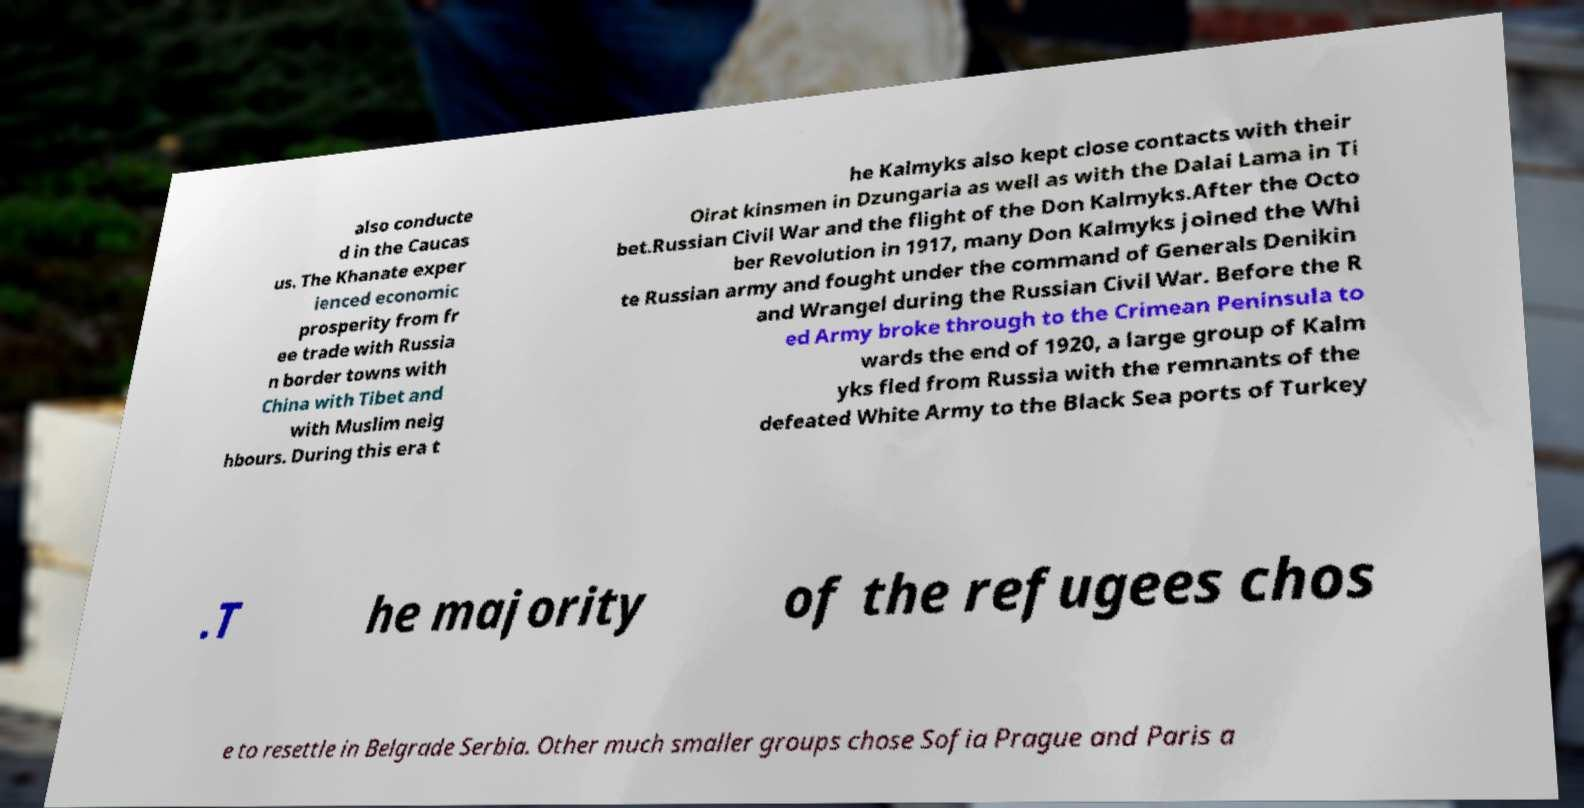Can you read and provide the text displayed in the image?This photo seems to have some interesting text. Can you extract and type it out for me? also conducte d in the Caucas us. The Khanate exper ienced economic prosperity from fr ee trade with Russia n border towns with China with Tibet and with Muslim neig hbours. During this era t he Kalmyks also kept close contacts with their Oirat kinsmen in Dzungaria as well as with the Dalai Lama in Ti bet.Russian Civil War and the flight of the Don Kalmyks.After the Octo ber Revolution in 1917, many Don Kalmyks joined the Whi te Russian army and fought under the command of Generals Denikin and Wrangel during the Russian Civil War. Before the R ed Army broke through to the Crimean Peninsula to wards the end of 1920, a large group of Kalm yks fled from Russia with the remnants of the defeated White Army to the Black Sea ports of Turkey .T he majority of the refugees chos e to resettle in Belgrade Serbia. Other much smaller groups chose Sofia Prague and Paris a 